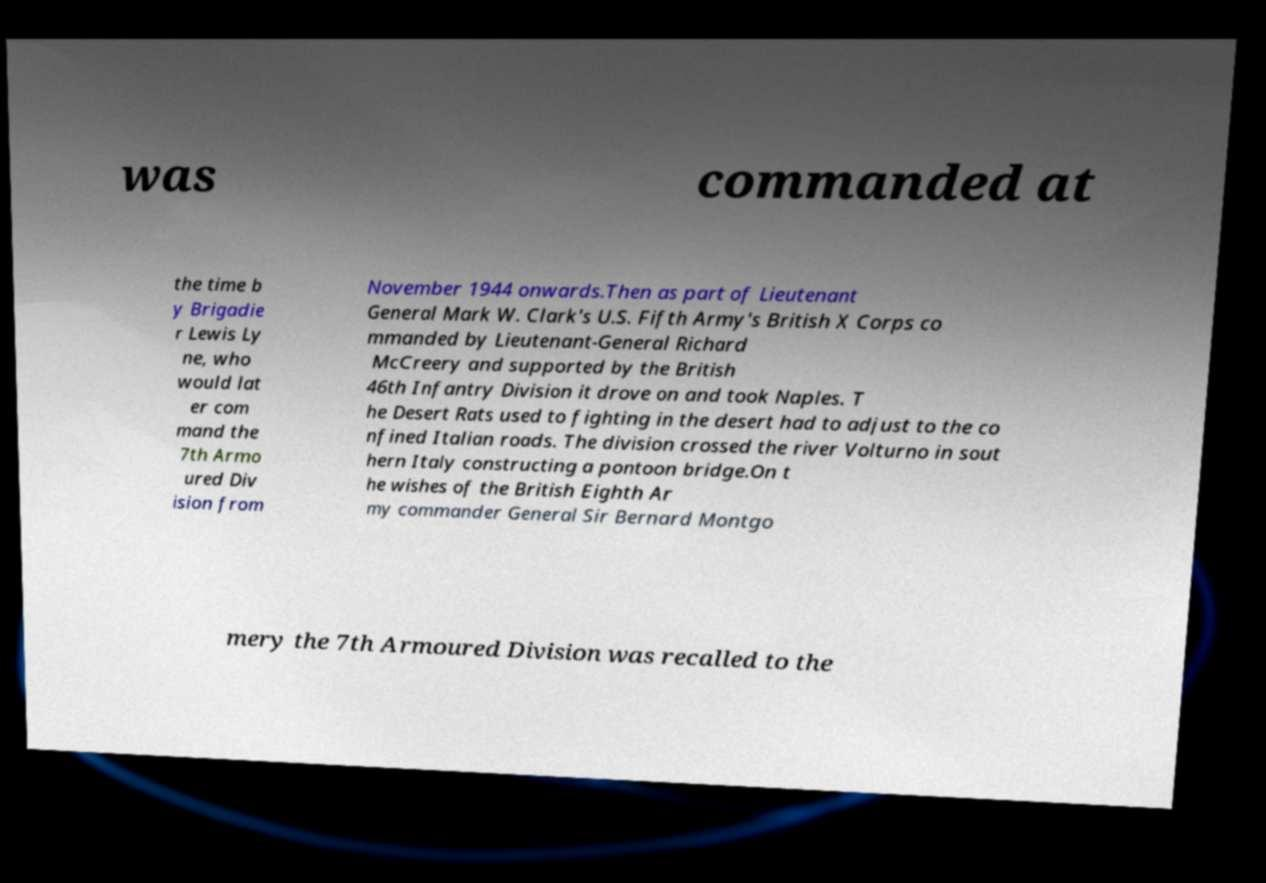Could you extract and type out the text from this image? was commanded at the time b y Brigadie r Lewis Ly ne, who would lat er com mand the 7th Armo ured Div ision from November 1944 onwards.Then as part of Lieutenant General Mark W. Clark's U.S. Fifth Army's British X Corps co mmanded by Lieutenant-General Richard McCreery and supported by the British 46th Infantry Division it drove on and took Naples. T he Desert Rats used to fighting in the desert had to adjust to the co nfined Italian roads. The division crossed the river Volturno in sout hern Italy constructing a pontoon bridge.On t he wishes of the British Eighth Ar my commander General Sir Bernard Montgo mery the 7th Armoured Division was recalled to the 